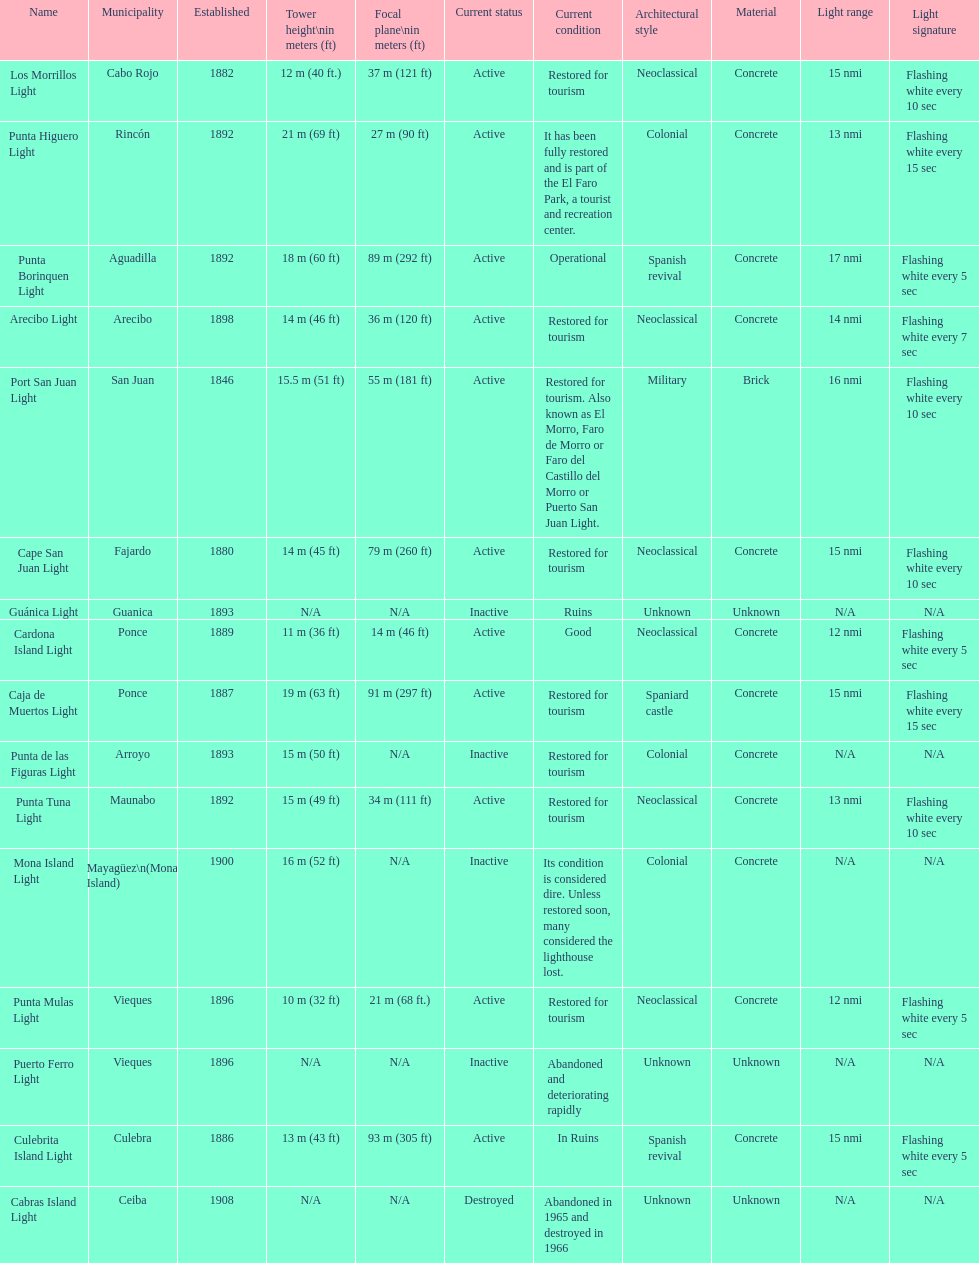Which municipality was the first to be established? San Juan. 